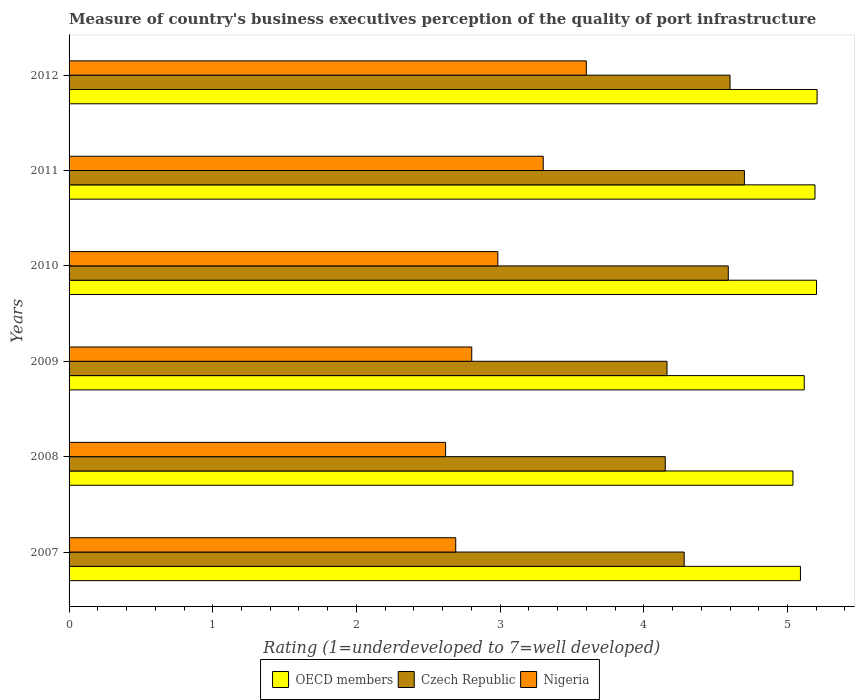How many groups of bars are there?
Your answer should be compact. 6. Are the number of bars on each tick of the Y-axis equal?
Provide a short and direct response. Yes. How many bars are there on the 2nd tick from the top?
Offer a very short reply. 3. How many bars are there on the 6th tick from the bottom?
Offer a very short reply. 3. What is the label of the 5th group of bars from the top?
Give a very brief answer. 2008. In how many cases, is the number of bars for a given year not equal to the number of legend labels?
Give a very brief answer. 0. What is the ratings of the quality of port infrastructure in Czech Republic in 2008?
Offer a very short reply. 4.15. Across all years, what is the minimum ratings of the quality of port infrastructure in Czech Republic?
Make the answer very short. 4.15. In which year was the ratings of the quality of port infrastructure in Czech Republic minimum?
Ensure brevity in your answer.  2008. What is the total ratings of the quality of port infrastructure in Nigeria in the graph?
Provide a short and direct response. 18. What is the difference between the ratings of the quality of port infrastructure in OECD members in 2007 and that in 2012?
Ensure brevity in your answer.  -0.12. What is the difference between the ratings of the quality of port infrastructure in Czech Republic in 2008 and the ratings of the quality of port infrastructure in Nigeria in 2012?
Your response must be concise. 0.55. What is the average ratings of the quality of port infrastructure in OECD members per year?
Provide a short and direct response. 5.14. In the year 2011, what is the difference between the ratings of the quality of port infrastructure in Nigeria and ratings of the quality of port infrastructure in Czech Republic?
Ensure brevity in your answer.  -1.4. What is the ratio of the ratings of the quality of port infrastructure in Czech Republic in 2007 to that in 2008?
Provide a succinct answer. 1.03. Is the ratings of the quality of port infrastructure in Czech Republic in 2009 less than that in 2010?
Your answer should be compact. Yes. What is the difference between the highest and the second highest ratings of the quality of port infrastructure in Czech Republic?
Give a very brief answer. 0.1. What is the difference between the highest and the lowest ratings of the quality of port infrastructure in Czech Republic?
Ensure brevity in your answer.  0.55. Is the sum of the ratings of the quality of port infrastructure in Nigeria in 2007 and 2009 greater than the maximum ratings of the quality of port infrastructure in OECD members across all years?
Give a very brief answer. Yes. What does the 2nd bar from the bottom in 2010 represents?
Your response must be concise. Czech Republic. Is it the case that in every year, the sum of the ratings of the quality of port infrastructure in Czech Republic and ratings of the quality of port infrastructure in OECD members is greater than the ratings of the quality of port infrastructure in Nigeria?
Offer a very short reply. Yes. Does the graph contain grids?
Your answer should be very brief. No. How many legend labels are there?
Give a very brief answer. 3. How are the legend labels stacked?
Give a very brief answer. Horizontal. What is the title of the graph?
Your answer should be very brief. Measure of country's business executives perception of the quality of port infrastructure. Does "Chile" appear as one of the legend labels in the graph?
Offer a terse response. No. What is the label or title of the X-axis?
Your response must be concise. Rating (1=underdeveloped to 7=well developed). What is the label or title of the Y-axis?
Your answer should be compact. Years. What is the Rating (1=underdeveloped to 7=well developed) in OECD members in 2007?
Keep it short and to the point. 5.09. What is the Rating (1=underdeveloped to 7=well developed) in Czech Republic in 2007?
Make the answer very short. 4.28. What is the Rating (1=underdeveloped to 7=well developed) of Nigeria in 2007?
Your answer should be compact. 2.69. What is the Rating (1=underdeveloped to 7=well developed) of OECD members in 2008?
Offer a very short reply. 5.04. What is the Rating (1=underdeveloped to 7=well developed) of Czech Republic in 2008?
Offer a terse response. 4.15. What is the Rating (1=underdeveloped to 7=well developed) in Nigeria in 2008?
Give a very brief answer. 2.62. What is the Rating (1=underdeveloped to 7=well developed) in OECD members in 2009?
Provide a succinct answer. 5.12. What is the Rating (1=underdeveloped to 7=well developed) in Czech Republic in 2009?
Make the answer very short. 4.16. What is the Rating (1=underdeveloped to 7=well developed) in Nigeria in 2009?
Provide a short and direct response. 2.8. What is the Rating (1=underdeveloped to 7=well developed) in OECD members in 2010?
Keep it short and to the point. 5.2. What is the Rating (1=underdeveloped to 7=well developed) of Czech Republic in 2010?
Provide a succinct answer. 4.59. What is the Rating (1=underdeveloped to 7=well developed) of Nigeria in 2010?
Your answer should be very brief. 2.98. What is the Rating (1=underdeveloped to 7=well developed) of OECD members in 2011?
Your answer should be very brief. 5.19. What is the Rating (1=underdeveloped to 7=well developed) of Czech Republic in 2011?
Give a very brief answer. 4.7. What is the Rating (1=underdeveloped to 7=well developed) of OECD members in 2012?
Offer a terse response. 5.21. What is the Rating (1=underdeveloped to 7=well developed) of Czech Republic in 2012?
Give a very brief answer. 4.6. What is the Rating (1=underdeveloped to 7=well developed) of Nigeria in 2012?
Offer a terse response. 3.6. Across all years, what is the maximum Rating (1=underdeveloped to 7=well developed) of OECD members?
Keep it short and to the point. 5.21. Across all years, what is the maximum Rating (1=underdeveloped to 7=well developed) of Czech Republic?
Your answer should be compact. 4.7. Across all years, what is the maximum Rating (1=underdeveloped to 7=well developed) of Nigeria?
Provide a short and direct response. 3.6. Across all years, what is the minimum Rating (1=underdeveloped to 7=well developed) in OECD members?
Keep it short and to the point. 5.04. Across all years, what is the minimum Rating (1=underdeveloped to 7=well developed) in Czech Republic?
Make the answer very short. 4.15. Across all years, what is the minimum Rating (1=underdeveloped to 7=well developed) of Nigeria?
Your answer should be compact. 2.62. What is the total Rating (1=underdeveloped to 7=well developed) of OECD members in the graph?
Your answer should be very brief. 30.84. What is the total Rating (1=underdeveloped to 7=well developed) of Czech Republic in the graph?
Provide a short and direct response. 26.48. What is the total Rating (1=underdeveloped to 7=well developed) in Nigeria in the graph?
Make the answer very short. 18. What is the difference between the Rating (1=underdeveloped to 7=well developed) of OECD members in 2007 and that in 2008?
Offer a very short reply. 0.05. What is the difference between the Rating (1=underdeveloped to 7=well developed) of Czech Republic in 2007 and that in 2008?
Your answer should be very brief. 0.13. What is the difference between the Rating (1=underdeveloped to 7=well developed) in Nigeria in 2007 and that in 2008?
Ensure brevity in your answer.  0.07. What is the difference between the Rating (1=underdeveloped to 7=well developed) of OECD members in 2007 and that in 2009?
Your answer should be compact. -0.03. What is the difference between the Rating (1=underdeveloped to 7=well developed) in Czech Republic in 2007 and that in 2009?
Keep it short and to the point. 0.12. What is the difference between the Rating (1=underdeveloped to 7=well developed) in Nigeria in 2007 and that in 2009?
Offer a very short reply. -0.11. What is the difference between the Rating (1=underdeveloped to 7=well developed) in OECD members in 2007 and that in 2010?
Provide a short and direct response. -0.11. What is the difference between the Rating (1=underdeveloped to 7=well developed) in Czech Republic in 2007 and that in 2010?
Keep it short and to the point. -0.31. What is the difference between the Rating (1=underdeveloped to 7=well developed) of Nigeria in 2007 and that in 2010?
Your response must be concise. -0.29. What is the difference between the Rating (1=underdeveloped to 7=well developed) in OECD members in 2007 and that in 2011?
Offer a terse response. -0.1. What is the difference between the Rating (1=underdeveloped to 7=well developed) in Czech Republic in 2007 and that in 2011?
Provide a short and direct response. -0.42. What is the difference between the Rating (1=underdeveloped to 7=well developed) in Nigeria in 2007 and that in 2011?
Provide a short and direct response. -0.61. What is the difference between the Rating (1=underdeveloped to 7=well developed) of OECD members in 2007 and that in 2012?
Your response must be concise. -0.12. What is the difference between the Rating (1=underdeveloped to 7=well developed) in Czech Republic in 2007 and that in 2012?
Your answer should be compact. -0.32. What is the difference between the Rating (1=underdeveloped to 7=well developed) in Nigeria in 2007 and that in 2012?
Keep it short and to the point. -0.91. What is the difference between the Rating (1=underdeveloped to 7=well developed) of OECD members in 2008 and that in 2009?
Give a very brief answer. -0.08. What is the difference between the Rating (1=underdeveloped to 7=well developed) in Czech Republic in 2008 and that in 2009?
Provide a succinct answer. -0.01. What is the difference between the Rating (1=underdeveloped to 7=well developed) in Nigeria in 2008 and that in 2009?
Give a very brief answer. -0.18. What is the difference between the Rating (1=underdeveloped to 7=well developed) of OECD members in 2008 and that in 2010?
Provide a succinct answer. -0.16. What is the difference between the Rating (1=underdeveloped to 7=well developed) of Czech Republic in 2008 and that in 2010?
Keep it short and to the point. -0.44. What is the difference between the Rating (1=underdeveloped to 7=well developed) in Nigeria in 2008 and that in 2010?
Keep it short and to the point. -0.36. What is the difference between the Rating (1=underdeveloped to 7=well developed) of OECD members in 2008 and that in 2011?
Offer a very short reply. -0.15. What is the difference between the Rating (1=underdeveloped to 7=well developed) of Czech Republic in 2008 and that in 2011?
Your answer should be compact. -0.55. What is the difference between the Rating (1=underdeveloped to 7=well developed) in Nigeria in 2008 and that in 2011?
Keep it short and to the point. -0.68. What is the difference between the Rating (1=underdeveloped to 7=well developed) in OECD members in 2008 and that in 2012?
Give a very brief answer. -0.17. What is the difference between the Rating (1=underdeveloped to 7=well developed) of Czech Republic in 2008 and that in 2012?
Your response must be concise. -0.45. What is the difference between the Rating (1=underdeveloped to 7=well developed) of Nigeria in 2008 and that in 2012?
Keep it short and to the point. -0.98. What is the difference between the Rating (1=underdeveloped to 7=well developed) in OECD members in 2009 and that in 2010?
Offer a very short reply. -0.09. What is the difference between the Rating (1=underdeveloped to 7=well developed) in Czech Republic in 2009 and that in 2010?
Keep it short and to the point. -0.43. What is the difference between the Rating (1=underdeveloped to 7=well developed) of Nigeria in 2009 and that in 2010?
Provide a short and direct response. -0.18. What is the difference between the Rating (1=underdeveloped to 7=well developed) in OECD members in 2009 and that in 2011?
Keep it short and to the point. -0.07. What is the difference between the Rating (1=underdeveloped to 7=well developed) in Czech Republic in 2009 and that in 2011?
Offer a very short reply. -0.54. What is the difference between the Rating (1=underdeveloped to 7=well developed) in Nigeria in 2009 and that in 2011?
Your answer should be very brief. -0.5. What is the difference between the Rating (1=underdeveloped to 7=well developed) in OECD members in 2009 and that in 2012?
Offer a very short reply. -0.09. What is the difference between the Rating (1=underdeveloped to 7=well developed) in Czech Republic in 2009 and that in 2012?
Offer a very short reply. -0.44. What is the difference between the Rating (1=underdeveloped to 7=well developed) of Nigeria in 2009 and that in 2012?
Provide a short and direct response. -0.8. What is the difference between the Rating (1=underdeveloped to 7=well developed) in OECD members in 2010 and that in 2011?
Provide a succinct answer. 0.01. What is the difference between the Rating (1=underdeveloped to 7=well developed) of Czech Republic in 2010 and that in 2011?
Your response must be concise. -0.11. What is the difference between the Rating (1=underdeveloped to 7=well developed) in Nigeria in 2010 and that in 2011?
Provide a short and direct response. -0.32. What is the difference between the Rating (1=underdeveloped to 7=well developed) in OECD members in 2010 and that in 2012?
Keep it short and to the point. -0. What is the difference between the Rating (1=underdeveloped to 7=well developed) in Czech Republic in 2010 and that in 2012?
Offer a very short reply. -0.01. What is the difference between the Rating (1=underdeveloped to 7=well developed) in Nigeria in 2010 and that in 2012?
Give a very brief answer. -0.62. What is the difference between the Rating (1=underdeveloped to 7=well developed) in OECD members in 2011 and that in 2012?
Make the answer very short. -0.01. What is the difference between the Rating (1=underdeveloped to 7=well developed) in Czech Republic in 2011 and that in 2012?
Your response must be concise. 0.1. What is the difference between the Rating (1=underdeveloped to 7=well developed) in OECD members in 2007 and the Rating (1=underdeveloped to 7=well developed) in Czech Republic in 2008?
Give a very brief answer. 0.94. What is the difference between the Rating (1=underdeveloped to 7=well developed) of OECD members in 2007 and the Rating (1=underdeveloped to 7=well developed) of Nigeria in 2008?
Offer a very short reply. 2.47. What is the difference between the Rating (1=underdeveloped to 7=well developed) in Czech Republic in 2007 and the Rating (1=underdeveloped to 7=well developed) in Nigeria in 2008?
Provide a succinct answer. 1.66. What is the difference between the Rating (1=underdeveloped to 7=well developed) of OECD members in 2007 and the Rating (1=underdeveloped to 7=well developed) of Czech Republic in 2009?
Ensure brevity in your answer.  0.93. What is the difference between the Rating (1=underdeveloped to 7=well developed) of OECD members in 2007 and the Rating (1=underdeveloped to 7=well developed) of Nigeria in 2009?
Offer a terse response. 2.29. What is the difference between the Rating (1=underdeveloped to 7=well developed) of Czech Republic in 2007 and the Rating (1=underdeveloped to 7=well developed) of Nigeria in 2009?
Ensure brevity in your answer.  1.48. What is the difference between the Rating (1=underdeveloped to 7=well developed) of OECD members in 2007 and the Rating (1=underdeveloped to 7=well developed) of Czech Republic in 2010?
Make the answer very short. 0.5. What is the difference between the Rating (1=underdeveloped to 7=well developed) in OECD members in 2007 and the Rating (1=underdeveloped to 7=well developed) in Nigeria in 2010?
Ensure brevity in your answer.  2.11. What is the difference between the Rating (1=underdeveloped to 7=well developed) in Czech Republic in 2007 and the Rating (1=underdeveloped to 7=well developed) in Nigeria in 2010?
Provide a short and direct response. 1.3. What is the difference between the Rating (1=underdeveloped to 7=well developed) of OECD members in 2007 and the Rating (1=underdeveloped to 7=well developed) of Czech Republic in 2011?
Your answer should be very brief. 0.39. What is the difference between the Rating (1=underdeveloped to 7=well developed) in OECD members in 2007 and the Rating (1=underdeveloped to 7=well developed) in Nigeria in 2011?
Your answer should be very brief. 1.79. What is the difference between the Rating (1=underdeveloped to 7=well developed) of Czech Republic in 2007 and the Rating (1=underdeveloped to 7=well developed) of Nigeria in 2011?
Your answer should be very brief. 0.98. What is the difference between the Rating (1=underdeveloped to 7=well developed) of OECD members in 2007 and the Rating (1=underdeveloped to 7=well developed) of Czech Republic in 2012?
Your answer should be very brief. 0.49. What is the difference between the Rating (1=underdeveloped to 7=well developed) of OECD members in 2007 and the Rating (1=underdeveloped to 7=well developed) of Nigeria in 2012?
Offer a terse response. 1.49. What is the difference between the Rating (1=underdeveloped to 7=well developed) in Czech Republic in 2007 and the Rating (1=underdeveloped to 7=well developed) in Nigeria in 2012?
Offer a terse response. 0.68. What is the difference between the Rating (1=underdeveloped to 7=well developed) in OECD members in 2008 and the Rating (1=underdeveloped to 7=well developed) in Czech Republic in 2009?
Give a very brief answer. 0.88. What is the difference between the Rating (1=underdeveloped to 7=well developed) of OECD members in 2008 and the Rating (1=underdeveloped to 7=well developed) of Nigeria in 2009?
Ensure brevity in your answer.  2.24. What is the difference between the Rating (1=underdeveloped to 7=well developed) of Czech Republic in 2008 and the Rating (1=underdeveloped to 7=well developed) of Nigeria in 2009?
Offer a very short reply. 1.35. What is the difference between the Rating (1=underdeveloped to 7=well developed) in OECD members in 2008 and the Rating (1=underdeveloped to 7=well developed) in Czech Republic in 2010?
Offer a very short reply. 0.45. What is the difference between the Rating (1=underdeveloped to 7=well developed) of OECD members in 2008 and the Rating (1=underdeveloped to 7=well developed) of Nigeria in 2010?
Ensure brevity in your answer.  2.05. What is the difference between the Rating (1=underdeveloped to 7=well developed) in Czech Republic in 2008 and the Rating (1=underdeveloped to 7=well developed) in Nigeria in 2010?
Keep it short and to the point. 1.17. What is the difference between the Rating (1=underdeveloped to 7=well developed) of OECD members in 2008 and the Rating (1=underdeveloped to 7=well developed) of Czech Republic in 2011?
Offer a very short reply. 0.34. What is the difference between the Rating (1=underdeveloped to 7=well developed) in OECD members in 2008 and the Rating (1=underdeveloped to 7=well developed) in Nigeria in 2011?
Ensure brevity in your answer.  1.74. What is the difference between the Rating (1=underdeveloped to 7=well developed) in Czech Republic in 2008 and the Rating (1=underdeveloped to 7=well developed) in Nigeria in 2011?
Make the answer very short. 0.85. What is the difference between the Rating (1=underdeveloped to 7=well developed) in OECD members in 2008 and the Rating (1=underdeveloped to 7=well developed) in Czech Republic in 2012?
Offer a very short reply. 0.44. What is the difference between the Rating (1=underdeveloped to 7=well developed) in OECD members in 2008 and the Rating (1=underdeveloped to 7=well developed) in Nigeria in 2012?
Give a very brief answer. 1.44. What is the difference between the Rating (1=underdeveloped to 7=well developed) of Czech Republic in 2008 and the Rating (1=underdeveloped to 7=well developed) of Nigeria in 2012?
Your answer should be very brief. 0.55. What is the difference between the Rating (1=underdeveloped to 7=well developed) in OECD members in 2009 and the Rating (1=underdeveloped to 7=well developed) in Czech Republic in 2010?
Your response must be concise. 0.53. What is the difference between the Rating (1=underdeveloped to 7=well developed) of OECD members in 2009 and the Rating (1=underdeveloped to 7=well developed) of Nigeria in 2010?
Your answer should be compact. 2.13. What is the difference between the Rating (1=underdeveloped to 7=well developed) in Czech Republic in 2009 and the Rating (1=underdeveloped to 7=well developed) in Nigeria in 2010?
Your answer should be very brief. 1.18. What is the difference between the Rating (1=underdeveloped to 7=well developed) of OECD members in 2009 and the Rating (1=underdeveloped to 7=well developed) of Czech Republic in 2011?
Give a very brief answer. 0.42. What is the difference between the Rating (1=underdeveloped to 7=well developed) of OECD members in 2009 and the Rating (1=underdeveloped to 7=well developed) of Nigeria in 2011?
Ensure brevity in your answer.  1.82. What is the difference between the Rating (1=underdeveloped to 7=well developed) of Czech Republic in 2009 and the Rating (1=underdeveloped to 7=well developed) of Nigeria in 2011?
Make the answer very short. 0.86. What is the difference between the Rating (1=underdeveloped to 7=well developed) in OECD members in 2009 and the Rating (1=underdeveloped to 7=well developed) in Czech Republic in 2012?
Your answer should be compact. 0.52. What is the difference between the Rating (1=underdeveloped to 7=well developed) in OECD members in 2009 and the Rating (1=underdeveloped to 7=well developed) in Nigeria in 2012?
Make the answer very short. 1.52. What is the difference between the Rating (1=underdeveloped to 7=well developed) of Czech Republic in 2009 and the Rating (1=underdeveloped to 7=well developed) of Nigeria in 2012?
Provide a short and direct response. 0.56. What is the difference between the Rating (1=underdeveloped to 7=well developed) of OECD members in 2010 and the Rating (1=underdeveloped to 7=well developed) of Czech Republic in 2011?
Your answer should be compact. 0.5. What is the difference between the Rating (1=underdeveloped to 7=well developed) of OECD members in 2010 and the Rating (1=underdeveloped to 7=well developed) of Nigeria in 2011?
Your answer should be compact. 1.9. What is the difference between the Rating (1=underdeveloped to 7=well developed) of Czech Republic in 2010 and the Rating (1=underdeveloped to 7=well developed) of Nigeria in 2011?
Keep it short and to the point. 1.29. What is the difference between the Rating (1=underdeveloped to 7=well developed) of OECD members in 2010 and the Rating (1=underdeveloped to 7=well developed) of Czech Republic in 2012?
Provide a short and direct response. 0.6. What is the difference between the Rating (1=underdeveloped to 7=well developed) in OECD members in 2010 and the Rating (1=underdeveloped to 7=well developed) in Nigeria in 2012?
Give a very brief answer. 1.6. What is the difference between the Rating (1=underdeveloped to 7=well developed) in Czech Republic in 2010 and the Rating (1=underdeveloped to 7=well developed) in Nigeria in 2012?
Provide a short and direct response. 0.99. What is the difference between the Rating (1=underdeveloped to 7=well developed) in OECD members in 2011 and the Rating (1=underdeveloped to 7=well developed) in Czech Republic in 2012?
Your answer should be very brief. 0.59. What is the difference between the Rating (1=underdeveloped to 7=well developed) in OECD members in 2011 and the Rating (1=underdeveloped to 7=well developed) in Nigeria in 2012?
Give a very brief answer. 1.59. What is the average Rating (1=underdeveloped to 7=well developed) in OECD members per year?
Your answer should be very brief. 5.14. What is the average Rating (1=underdeveloped to 7=well developed) of Czech Republic per year?
Offer a very short reply. 4.41. What is the average Rating (1=underdeveloped to 7=well developed) of Nigeria per year?
Provide a short and direct response. 3. In the year 2007, what is the difference between the Rating (1=underdeveloped to 7=well developed) of OECD members and Rating (1=underdeveloped to 7=well developed) of Czech Republic?
Provide a short and direct response. 0.81. In the year 2007, what is the difference between the Rating (1=underdeveloped to 7=well developed) in OECD members and Rating (1=underdeveloped to 7=well developed) in Nigeria?
Ensure brevity in your answer.  2.4. In the year 2007, what is the difference between the Rating (1=underdeveloped to 7=well developed) in Czech Republic and Rating (1=underdeveloped to 7=well developed) in Nigeria?
Provide a short and direct response. 1.59. In the year 2008, what is the difference between the Rating (1=underdeveloped to 7=well developed) in OECD members and Rating (1=underdeveloped to 7=well developed) in Czech Republic?
Offer a very short reply. 0.89. In the year 2008, what is the difference between the Rating (1=underdeveloped to 7=well developed) in OECD members and Rating (1=underdeveloped to 7=well developed) in Nigeria?
Provide a succinct answer. 2.42. In the year 2008, what is the difference between the Rating (1=underdeveloped to 7=well developed) in Czech Republic and Rating (1=underdeveloped to 7=well developed) in Nigeria?
Keep it short and to the point. 1.53. In the year 2009, what is the difference between the Rating (1=underdeveloped to 7=well developed) in OECD members and Rating (1=underdeveloped to 7=well developed) in Czech Republic?
Give a very brief answer. 0.95. In the year 2009, what is the difference between the Rating (1=underdeveloped to 7=well developed) in OECD members and Rating (1=underdeveloped to 7=well developed) in Nigeria?
Offer a terse response. 2.31. In the year 2009, what is the difference between the Rating (1=underdeveloped to 7=well developed) of Czech Republic and Rating (1=underdeveloped to 7=well developed) of Nigeria?
Your response must be concise. 1.36. In the year 2010, what is the difference between the Rating (1=underdeveloped to 7=well developed) of OECD members and Rating (1=underdeveloped to 7=well developed) of Czech Republic?
Your response must be concise. 0.61. In the year 2010, what is the difference between the Rating (1=underdeveloped to 7=well developed) in OECD members and Rating (1=underdeveloped to 7=well developed) in Nigeria?
Give a very brief answer. 2.22. In the year 2010, what is the difference between the Rating (1=underdeveloped to 7=well developed) in Czech Republic and Rating (1=underdeveloped to 7=well developed) in Nigeria?
Keep it short and to the point. 1.6. In the year 2011, what is the difference between the Rating (1=underdeveloped to 7=well developed) of OECD members and Rating (1=underdeveloped to 7=well developed) of Czech Republic?
Provide a short and direct response. 0.49. In the year 2011, what is the difference between the Rating (1=underdeveloped to 7=well developed) of OECD members and Rating (1=underdeveloped to 7=well developed) of Nigeria?
Provide a short and direct response. 1.89. In the year 2011, what is the difference between the Rating (1=underdeveloped to 7=well developed) in Czech Republic and Rating (1=underdeveloped to 7=well developed) in Nigeria?
Your answer should be very brief. 1.4. In the year 2012, what is the difference between the Rating (1=underdeveloped to 7=well developed) of OECD members and Rating (1=underdeveloped to 7=well developed) of Czech Republic?
Your answer should be compact. 0.61. In the year 2012, what is the difference between the Rating (1=underdeveloped to 7=well developed) of OECD members and Rating (1=underdeveloped to 7=well developed) of Nigeria?
Offer a very short reply. 1.61. What is the ratio of the Rating (1=underdeveloped to 7=well developed) of OECD members in 2007 to that in 2008?
Your answer should be compact. 1.01. What is the ratio of the Rating (1=underdeveloped to 7=well developed) in Czech Republic in 2007 to that in 2008?
Keep it short and to the point. 1.03. What is the ratio of the Rating (1=underdeveloped to 7=well developed) in Nigeria in 2007 to that in 2008?
Your response must be concise. 1.03. What is the ratio of the Rating (1=underdeveloped to 7=well developed) in Czech Republic in 2007 to that in 2009?
Offer a terse response. 1.03. What is the ratio of the Rating (1=underdeveloped to 7=well developed) in Nigeria in 2007 to that in 2009?
Your answer should be very brief. 0.96. What is the ratio of the Rating (1=underdeveloped to 7=well developed) of OECD members in 2007 to that in 2010?
Give a very brief answer. 0.98. What is the ratio of the Rating (1=underdeveloped to 7=well developed) in Czech Republic in 2007 to that in 2010?
Keep it short and to the point. 0.93. What is the ratio of the Rating (1=underdeveloped to 7=well developed) in Nigeria in 2007 to that in 2010?
Your answer should be very brief. 0.9. What is the ratio of the Rating (1=underdeveloped to 7=well developed) in OECD members in 2007 to that in 2011?
Ensure brevity in your answer.  0.98. What is the ratio of the Rating (1=underdeveloped to 7=well developed) in Czech Republic in 2007 to that in 2011?
Make the answer very short. 0.91. What is the ratio of the Rating (1=underdeveloped to 7=well developed) in Nigeria in 2007 to that in 2011?
Your answer should be very brief. 0.82. What is the ratio of the Rating (1=underdeveloped to 7=well developed) of OECD members in 2007 to that in 2012?
Make the answer very short. 0.98. What is the ratio of the Rating (1=underdeveloped to 7=well developed) in Czech Republic in 2007 to that in 2012?
Your answer should be very brief. 0.93. What is the ratio of the Rating (1=underdeveloped to 7=well developed) of Nigeria in 2007 to that in 2012?
Provide a short and direct response. 0.75. What is the ratio of the Rating (1=underdeveloped to 7=well developed) of OECD members in 2008 to that in 2009?
Offer a very short reply. 0.98. What is the ratio of the Rating (1=underdeveloped to 7=well developed) in Czech Republic in 2008 to that in 2009?
Keep it short and to the point. 1. What is the ratio of the Rating (1=underdeveloped to 7=well developed) of Nigeria in 2008 to that in 2009?
Provide a succinct answer. 0.94. What is the ratio of the Rating (1=underdeveloped to 7=well developed) in OECD members in 2008 to that in 2010?
Make the answer very short. 0.97. What is the ratio of the Rating (1=underdeveloped to 7=well developed) in Czech Republic in 2008 to that in 2010?
Provide a short and direct response. 0.9. What is the ratio of the Rating (1=underdeveloped to 7=well developed) of Nigeria in 2008 to that in 2010?
Offer a terse response. 0.88. What is the ratio of the Rating (1=underdeveloped to 7=well developed) of OECD members in 2008 to that in 2011?
Provide a short and direct response. 0.97. What is the ratio of the Rating (1=underdeveloped to 7=well developed) in Czech Republic in 2008 to that in 2011?
Keep it short and to the point. 0.88. What is the ratio of the Rating (1=underdeveloped to 7=well developed) in Nigeria in 2008 to that in 2011?
Your answer should be compact. 0.79. What is the ratio of the Rating (1=underdeveloped to 7=well developed) in OECD members in 2008 to that in 2012?
Your answer should be compact. 0.97. What is the ratio of the Rating (1=underdeveloped to 7=well developed) of Czech Republic in 2008 to that in 2012?
Provide a succinct answer. 0.9. What is the ratio of the Rating (1=underdeveloped to 7=well developed) in Nigeria in 2008 to that in 2012?
Make the answer very short. 0.73. What is the ratio of the Rating (1=underdeveloped to 7=well developed) of OECD members in 2009 to that in 2010?
Offer a terse response. 0.98. What is the ratio of the Rating (1=underdeveloped to 7=well developed) of Czech Republic in 2009 to that in 2010?
Offer a terse response. 0.91. What is the ratio of the Rating (1=underdeveloped to 7=well developed) of Nigeria in 2009 to that in 2010?
Provide a succinct answer. 0.94. What is the ratio of the Rating (1=underdeveloped to 7=well developed) in OECD members in 2009 to that in 2011?
Your answer should be compact. 0.99. What is the ratio of the Rating (1=underdeveloped to 7=well developed) in Czech Republic in 2009 to that in 2011?
Your answer should be compact. 0.89. What is the ratio of the Rating (1=underdeveloped to 7=well developed) of Nigeria in 2009 to that in 2011?
Make the answer very short. 0.85. What is the ratio of the Rating (1=underdeveloped to 7=well developed) in OECD members in 2009 to that in 2012?
Keep it short and to the point. 0.98. What is the ratio of the Rating (1=underdeveloped to 7=well developed) of Czech Republic in 2009 to that in 2012?
Make the answer very short. 0.9. What is the ratio of the Rating (1=underdeveloped to 7=well developed) of Nigeria in 2009 to that in 2012?
Give a very brief answer. 0.78. What is the ratio of the Rating (1=underdeveloped to 7=well developed) of Czech Republic in 2010 to that in 2011?
Provide a short and direct response. 0.98. What is the ratio of the Rating (1=underdeveloped to 7=well developed) of Nigeria in 2010 to that in 2011?
Make the answer very short. 0.9. What is the ratio of the Rating (1=underdeveloped to 7=well developed) in OECD members in 2010 to that in 2012?
Provide a short and direct response. 1. What is the ratio of the Rating (1=underdeveloped to 7=well developed) in Nigeria in 2010 to that in 2012?
Your answer should be compact. 0.83. What is the ratio of the Rating (1=underdeveloped to 7=well developed) in Czech Republic in 2011 to that in 2012?
Your answer should be compact. 1.02. What is the ratio of the Rating (1=underdeveloped to 7=well developed) of Nigeria in 2011 to that in 2012?
Your response must be concise. 0.92. What is the difference between the highest and the second highest Rating (1=underdeveloped to 7=well developed) in OECD members?
Give a very brief answer. 0. What is the difference between the highest and the lowest Rating (1=underdeveloped to 7=well developed) in OECD members?
Offer a very short reply. 0.17. What is the difference between the highest and the lowest Rating (1=underdeveloped to 7=well developed) of Czech Republic?
Your answer should be compact. 0.55. What is the difference between the highest and the lowest Rating (1=underdeveloped to 7=well developed) in Nigeria?
Your answer should be compact. 0.98. 